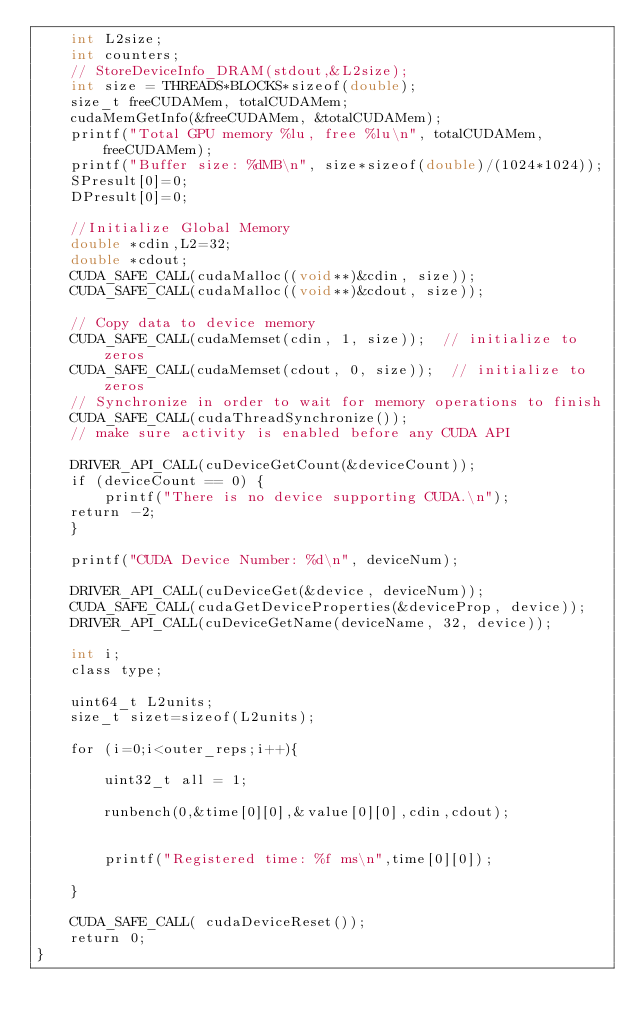Convert code to text. <code><loc_0><loc_0><loc_500><loc_500><_Cuda_>	int L2size;
	int counters;
	// StoreDeviceInfo_DRAM(stdout,&L2size);
	int size = THREADS*BLOCKS*sizeof(double);
	size_t freeCUDAMem, totalCUDAMem;
	cudaMemGetInfo(&freeCUDAMem, &totalCUDAMem);
	printf("Total GPU memory %lu, free %lu\n", totalCUDAMem, freeCUDAMem);
	printf("Buffer size: %dMB\n", size*sizeof(double)/(1024*1024));
	SPresult[0]=0;
	DPresult[0]=0;

	//Initialize Global Memory
	double *cdin,L2=32;
	double *cdout;
	CUDA_SAFE_CALL(cudaMalloc((void**)&cdin, size));
	CUDA_SAFE_CALL(cudaMalloc((void**)&cdout, size));

	// Copy data to device memory
	CUDA_SAFE_CALL(cudaMemset(cdin, 1, size));  // initialize to zeros
	CUDA_SAFE_CALL(cudaMemset(cdout, 0, size));  // initialize to zeros
	// Synchronize in order to wait for memory operations to finish
	CUDA_SAFE_CALL(cudaThreadSynchronize());
	// make sure activity is enabled before any CUDA API

	DRIVER_API_CALL(cuDeviceGetCount(&deviceCount));
	if (deviceCount == 0) {
		printf("There is no device supporting CUDA.\n");
	return -2;
	}

	printf("CUDA Device Number: %d\n", deviceNum);

	DRIVER_API_CALL(cuDeviceGet(&device, deviceNum));
	CUDA_SAFE_CALL(cudaGetDeviceProperties(&deviceProp, device));
	DRIVER_API_CALL(cuDeviceGetName(deviceName, 32, device));

	int i;
	class type;

	uint64_t L2units;
	size_t sizet=sizeof(L2units);

    for (i=0;i<outer_reps;i++){

        uint32_t all = 1;

		runbench(0,&time[0][0],&value[0][0],cdin,cdout);


        printf("Registered time: %f ms\n",time[0][0]);

    }

    CUDA_SAFE_CALL( cudaDeviceReset());
	return 0;
}
</code> 